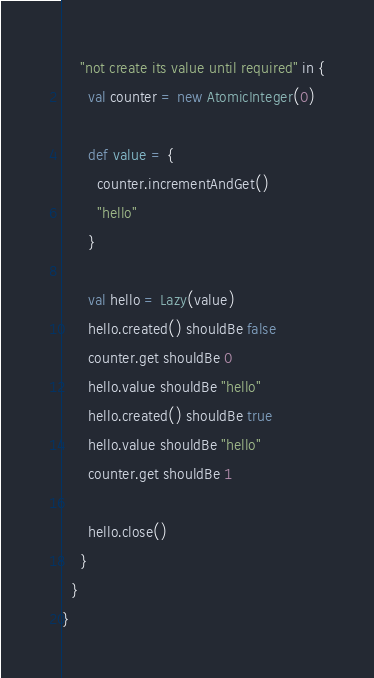<code> <loc_0><loc_0><loc_500><loc_500><_Scala_>    "not create its value until required" in {
      val counter = new AtomicInteger(0)

      def value = {
        counter.incrementAndGet()
        "hello"
      }

      val hello = Lazy(value)
      hello.created() shouldBe false
      counter.get shouldBe 0
      hello.value shouldBe "hello"
      hello.created() shouldBe true
      hello.value shouldBe "hello"
      counter.get shouldBe 1

      hello.close()
    }
  }
}
</code> 